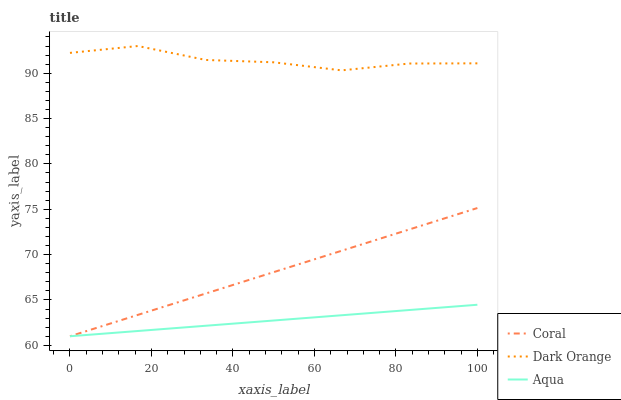Does Aqua have the minimum area under the curve?
Answer yes or no. Yes. Does Dark Orange have the maximum area under the curve?
Answer yes or no. Yes. Does Coral have the minimum area under the curve?
Answer yes or no. No. Does Coral have the maximum area under the curve?
Answer yes or no. No. Is Coral the smoothest?
Answer yes or no. Yes. Is Dark Orange the roughest?
Answer yes or no. Yes. Is Aqua the smoothest?
Answer yes or no. No. Is Aqua the roughest?
Answer yes or no. No. Does Coral have the lowest value?
Answer yes or no. Yes. Does Dark Orange have the highest value?
Answer yes or no. Yes. Does Coral have the highest value?
Answer yes or no. No. Is Aqua less than Dark Orange?
Answer yes or no. Yes. Is Dark Orange greater than Aqua?
Answer yes or no. Yes. Does Aqua intersect Coral?
Answer yes or no. Yes. Is Aqua less than Coral?
Answer yes or no. No. Is Aqua greater than Coral?
Answer yes or no. No. Does Aqua intersect Dark Orange?
Answer yes or no. No. 